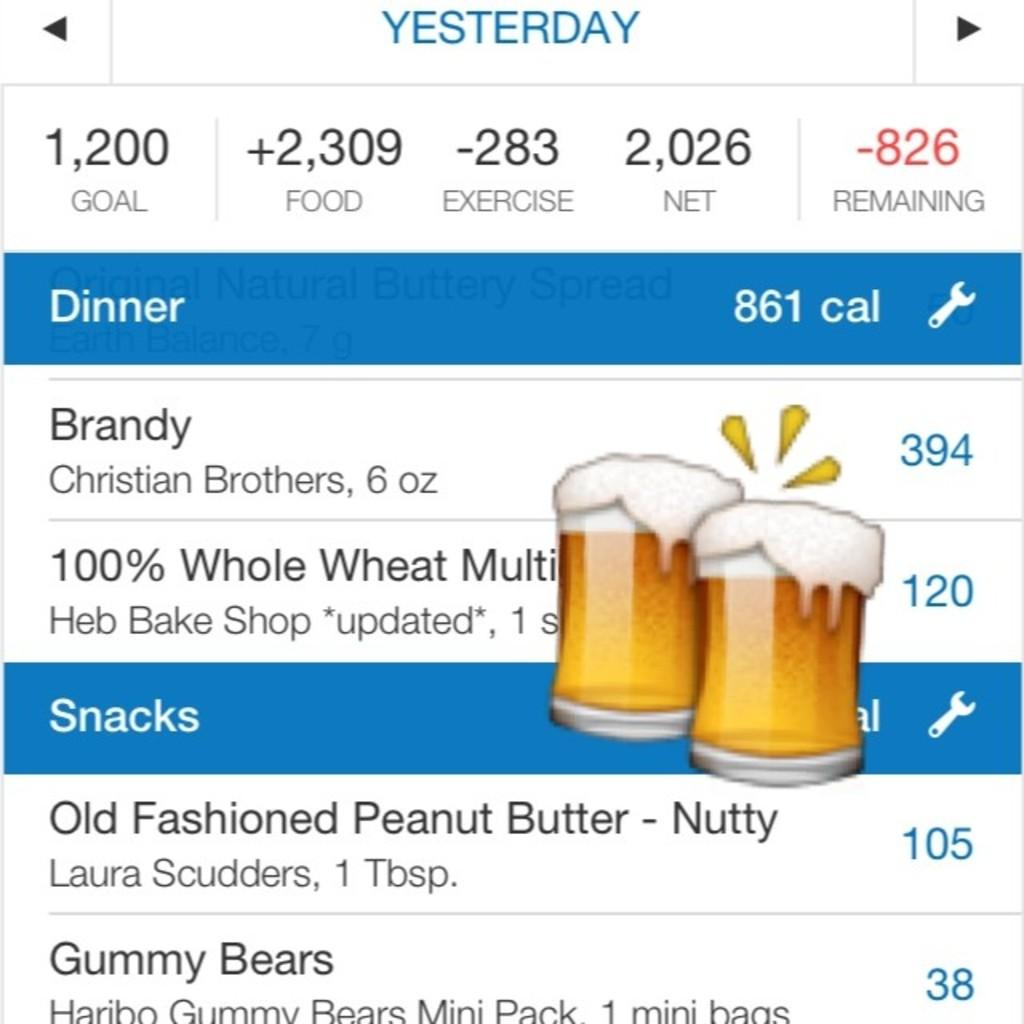<image>
Share a concise interpretation of the image provided. a page that is titled 'yesterday' and a small label that says 'dinner' 